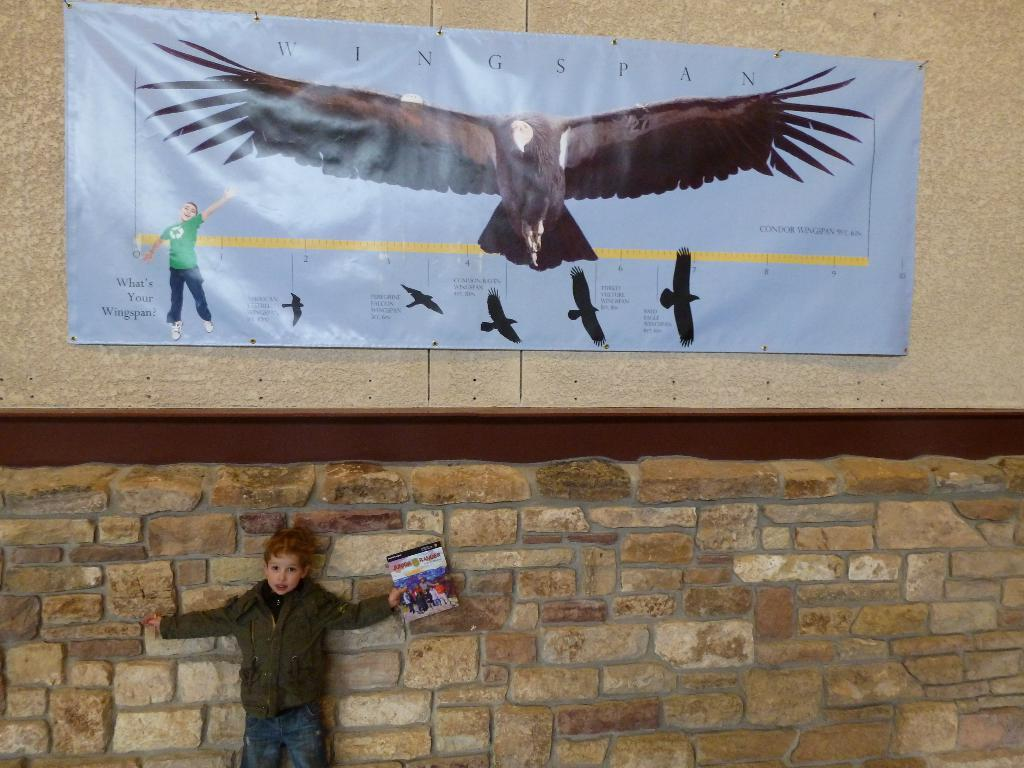What is the boy doing on the left side of the image? The boy is standing on the left side of the image. What is the boy holding in his hand? The boy is holding a book in his hand. What can be seen in the background of the image? There is a wall and a banner present in the background of the image. Can you see any animals from the zoo in the image? There is no mention of a zoo or any animals in the image. 